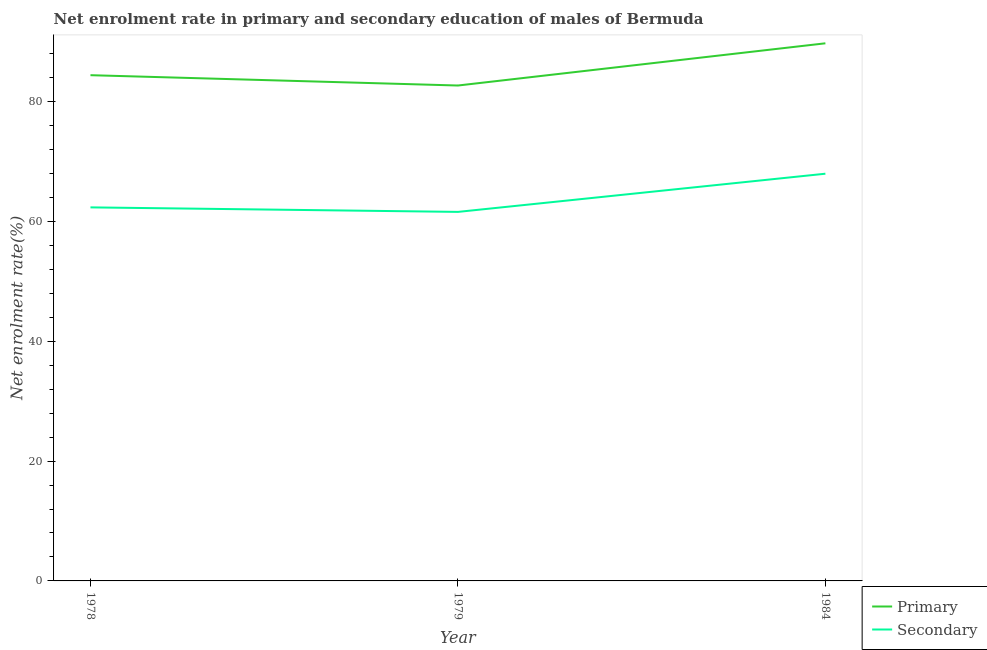Does the line corresponding to enrollment rate in primary education intersect with the line corresponding to enrollment rate in secondary education?
Provide a succinct answer. No. What is the enrollment rate in secondary education in 1984?
Make the answer very short. 67.95. Across all years, what is the maximum enrollment rate in secondary education?
Offer a terse response. 67.95. Across all years, what is the minimum enrollment rate in primary education?
Offer a very short reply. 82.66. In which year was the enrollment rate in secondary education minimum?
Your response must be concise. 1979. What is the total enrollment rate in primary education in the graph?
Your response must be concise. 256.75. What is the difference between the enrollment rate in primary education in 1978 and that in 1979?
Provide a succinct answer. 1.72. What is the difference between the enrollment rate in secondary education in 1979 and the enrollment rate in primary education in 1984?
Provide a short and direct response. -28.13. What is the average enrollment rate in secondary education per year?
Offer a terse response. 63.95. In the year 1978, what is the difference between the enrollment rate in secondary education and enrollment rate in primary education?
Your response must be concise. -22.06. In how many years, is the enrollment rate in secondary education greater than 44 %?
Offer a very short reply. 3. What is the ratio of the enrollment rate in primary education in 1978 to that in 1979?
Your response must be concise. 1.02. What is the difference between the highest and the second highest enrollment rate in secondary education?
Ensure brevity in your answer.  5.62. What is the difference between the highest and the lowest enrollment rate in secondary education?
Provide a succinct answer. 6.37. Is the sum of the enrollment rate in primary education in 1978 and 1984 greater than the maximum enrollment rate in secondary education across all years?
Offer a terse response. Yes. Is the enrollment rate in primary education strictly greater than the enrollment rate in secondary education over the years?
Ensure brevity in your answer.  Yes. Is the enrollment rate in secondary education strictly less than the enrollment rate in primary education over the years?
Give a very brief answer. Yes. How many lines are there?
Provide a succinct answer. 2. Where does the legend appear in the graph?
Make the answer very short. Bottom right. What is the title of the graph?
Provide a short and direct response. Net enrolment rate in primary and secondary education of males of Bermuda. What is the label or title of the Y-axis?
Your answer should be very brief. Net enrolment rate(%). What is the Net enrolment rate(%) in Primary in 1978?
Offer a terse response. 84.38. What is the Net enrolment rate(%) of Secondary in 1978?
Provide a short and direct response. 62.33. What is the Net enrolment rate(%) in Primary in 1979?
Your response must be concise. 82.66. What is the Net enrolment rate(%) in Secondary in 1979?
Keep it short and to the point. 61.57. What is the Net enrolment rate(%) of Primary in 1984?
Provide a short and direct response. 89.7. What is the Net enrolment rate(%) in Secondary in 1984?
Your answer should be compact. 67.95. Across all years, what is the maximum Net enrolment rate(%) in Primary?
Provide a succinct answer. 89.7. Across all years, what is the maximum Net enrolment rate(%) in Secondary?
Provide a short and direct response. 67.95. Across all years, what is the minimum Net enrolment rate(%) in Primary?
Your answer should be compact. 82.66. Across all years, what is the minimum Net enrolment rate(%) in Secondary?
Ensure brevity in your answer.  61.57. What is the total Net enrolment rate(%) in Primary in the graph?
Provide a short and direct response. 256.75. What is the total Net enrolment rate(%) in Secondary in the graph?
Provide a succinct answer. 191.85. What is the difference between the Net enrolment rate(%) in Primary in 1978 and that in 1979?
Offer a terse response. 1.72. What is the difference between the Net enrolment rate(%) of Secondary in 1978 and that in 1979?
Your answer should be compact. 0.75. What is the difference between the Net enrolment rate(%) in Primary in 1978 and that in 1984?
Your response must be concise. -5.32. What is the difference between the Net enrolment rate(%) in Secondary in 1978 and that in 1984?
Offer a very short reply. -5.62. What is the difference between the Net enrolment rate(%) of Primary in 1979 and that in 1984?
Provide a short and direct response. -7.04. What is the difference between the Net enrolment rate(%) in Secondary in 1979 and that in 1984?
Ensure brevity in your answer.  -6.37. What is the difference between the Net enrolment rate(%) in Primary in 1978 and the Net enrolment rate(%) in Secondary in 1979?
Provide a short and direct response. 22.81. What is the difference between the Net enrolment rate(%) in Primary in 1978 and the Net enrolment rate(%) in Secondary in 1984?
Your answer should be compact. 16.44. What is the difference between the Net enrolment rate(%) of Primary in 1979 and the Net enrolment rate(%) of Secondary in 1984?
Your response must be concise. 14.72. What is the average Net enrolment rate(%) of Primary per year?
Your answer should be very brief. 85.58. What is the average Net enrolment rate(%) in Secondary per year?
Your answer should be very brief. 63.95. In the year 1978, what is the difference between the Net enrolment rate(%) of Primary and Net enrolment rate(%) of Secondary?
Your answer should be very brief. 22.06. In the year 1979, what is the difference between the Net enrolment rate(%) of Primary and Net enrolment rate(%) of Secondary?
Make the answer very short. 21.09. In the year 1984, what is the difference between the Net enrolment rate(%) of Primary and Net enrolment rate(%) of Secondary?
Make the answer very short. 21.76. What is the ratio of the Net enrolment rate(%) in Primary in 1978 to that in 1979?
Provide a succinct answer. 1.02. What is the ratio of the Net enrolment rate(%) in Secondary in 1978 to that in 1979?
Your answer should be compact. 1.01. What is the ratio of the Net enrolment rate(%) in Primary in 1978 to that in 1984?
Give a very brief answer. 0.94. What is the ratio of the Net enrolment rate(%) in Secondary in 1978 to that in 1984?
Offer a terse response. 0.92. What is the ratio of the Net enrolment rate(%) in Primary in 1979 to that in 1984?
Offer a very short reply. 0.92. What is the ratio of the Net enrolment rate(%) in Secondary in 1979 to that in 1984?
Ensure brevity in your answer.  0.91. What is the difference between the highest and the second highest Net enrolment rate(%) of Primary?
Offer a terse response. 5.32. What is the difference between the highest and the second highest Net enrolment rate(%) of Secondary?
Provide a succinct answer. 5.62. What is the difference between the highest and the lowest Net enrolment rate(%) of Primary?
Offer a very short reply. 7.04. What is the difference between the highest and the lowest Net enrolment rate(%) of Secondary?
Offer a terse response. 6.37. 